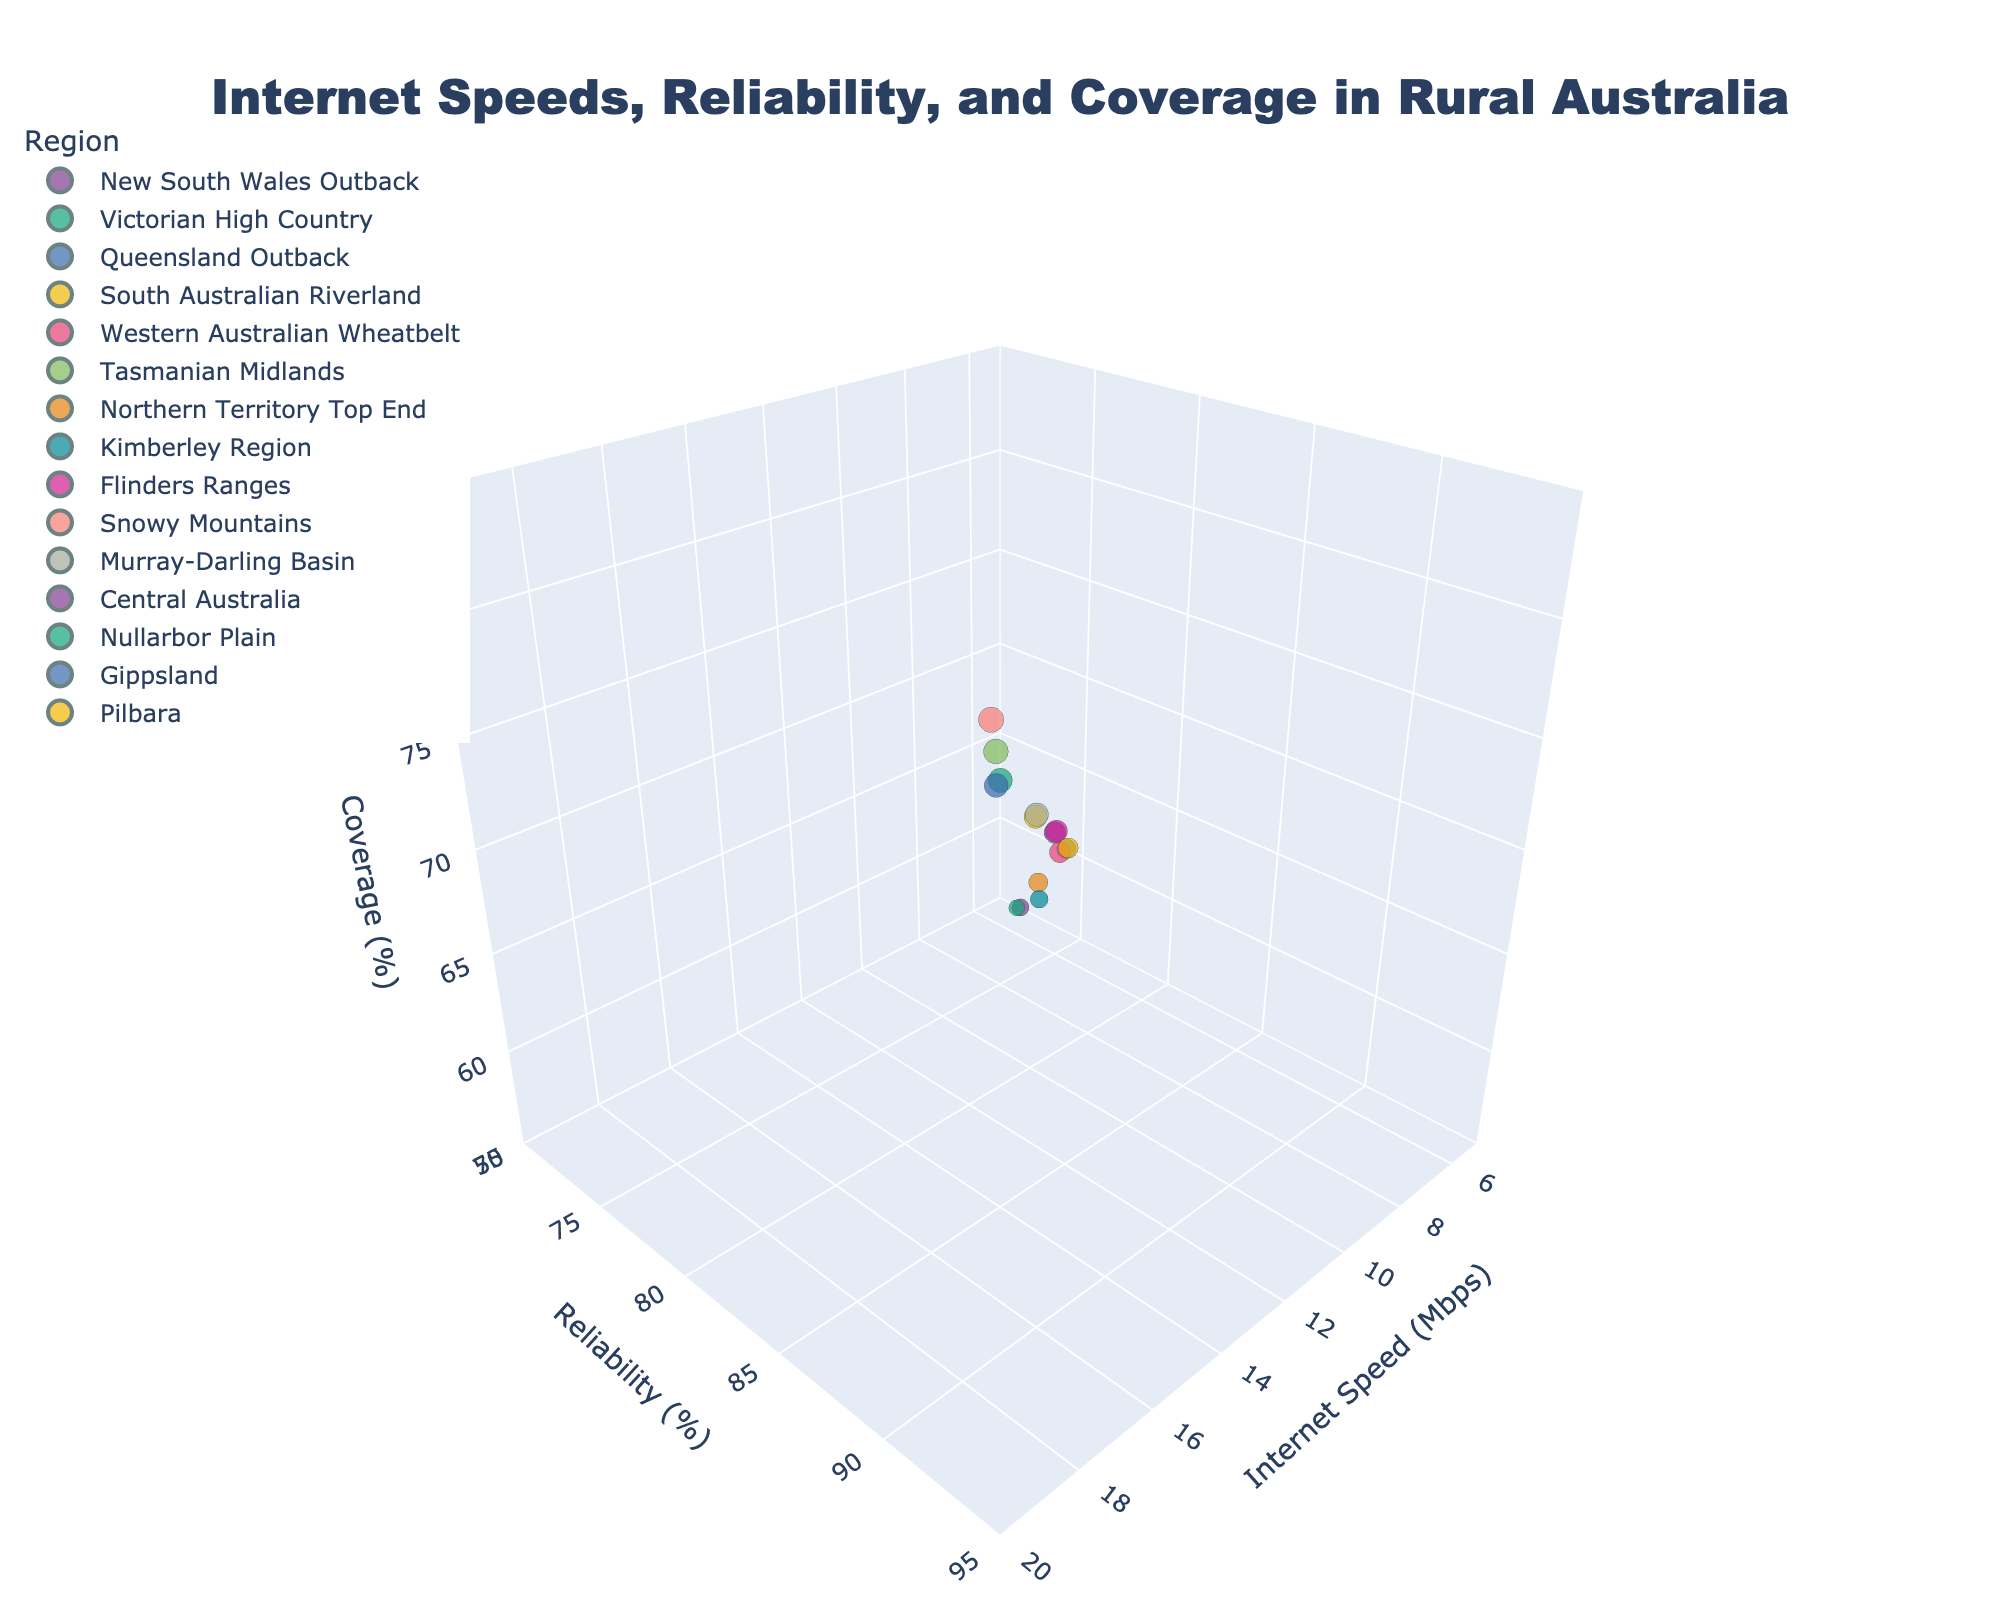Which region has the highest internet speed? To find the region with the highest internet speed, look at the marker that is farthest along the 'Internet Speed (Mbps)' axis. The marker for 'Snowy Mountains' is farthest along this axis.
Answer: Snowy Mountains What is the title of the plot? The title is prominently displayed at the top center of the plot.
Answer: Internet Speeds, Reliability, and Coverage in Rural Australia Which region has the lowest coverage percentage? To determine the region with the lowest coverage percentage, find the marker closest to the origin on the 'Coverage (%)' axis. The marker for 'Nullarbor Plain' is closest to the origin.
Answer: Nullarbor Plain How many data points are shown in the plot? Count the number of unique markers in the 3D space. Each marker represents a region, and there should be one for each region listed in the data. There are 15 regions listed.
Answer: 15 Which region has higher reliability, Flinders Ranges or Pilbara? Compare the positions of the markers for 'Flinders Ranges' and 'Pilbara' along the 'Reliability (%)' axis. 'Flinders Ranges' is closer to the higher values on the 'Reliability (%)' axis.
Answer: Flinders Ranges What is the average internet speed of the regions shown in the plot? Sum the internet speeds of all regions and divide by the number of regions. The sum of the internet speeds is 190.4 Mbps (12.5 + 15.8 + 10.2 + 14.3 + 11.7 + 16.5 + 9.8 + 8.5 + 13.1 + 17.2 + 14.9 + 7.9 + 6.8 + 15.3 + 10.8). The average is 190.4 / 15.
Answer: 12.69 Mbps Does New South Wales Outback have better coverage than Northern Territory Top End? Compare their positions along the 'Coverage (%)' axis. 'New South Wales Outback' is situated at 72%, while 'Northern Territory Top End' is at 65%.
Answer: Yes Which regions have an internet speed greater than 15 Mbps? Identify the markers with 'Internet Speed (Mbps)' values greater than 15. These regions are: 'Victorian High Country', 'Tasmanian Midlands', 'Snowy Mountains', and 'Gippsland'.
Answer: Victorian High Country, Tasmanian Midlands, Snowy Mountains, Gippsland What is the difference in coverage between South Australian Riverland and Murray-Darling Basin? Find the 'Coverage (%)' values for both regions and subtract one from the other. South Australian Riverland has 75% and Murray-Darling Basin has 76%. The difference is 76% - 75%.
Answer: 1% Which region has the closest balance between internet speed, reliability, and coverage? Find a marker that is roughly equidistant along all three axes. 'Snowy Mountains' appears to be fairly balanced with values of 17.2 Mbps for internet speed, 90% for reliability, and 82% for coverage.
Answer: Snowy Mountains 